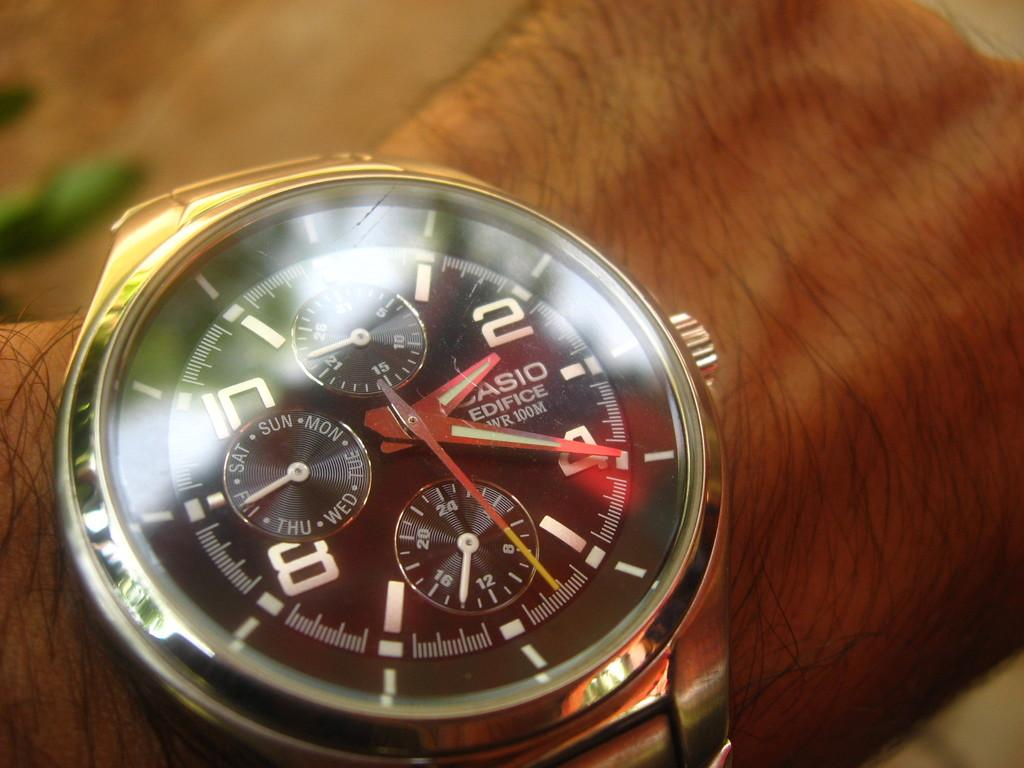Provide a one-sentence caption for the provided image. A person wears a Casio watch with many small dials on their wrist. 